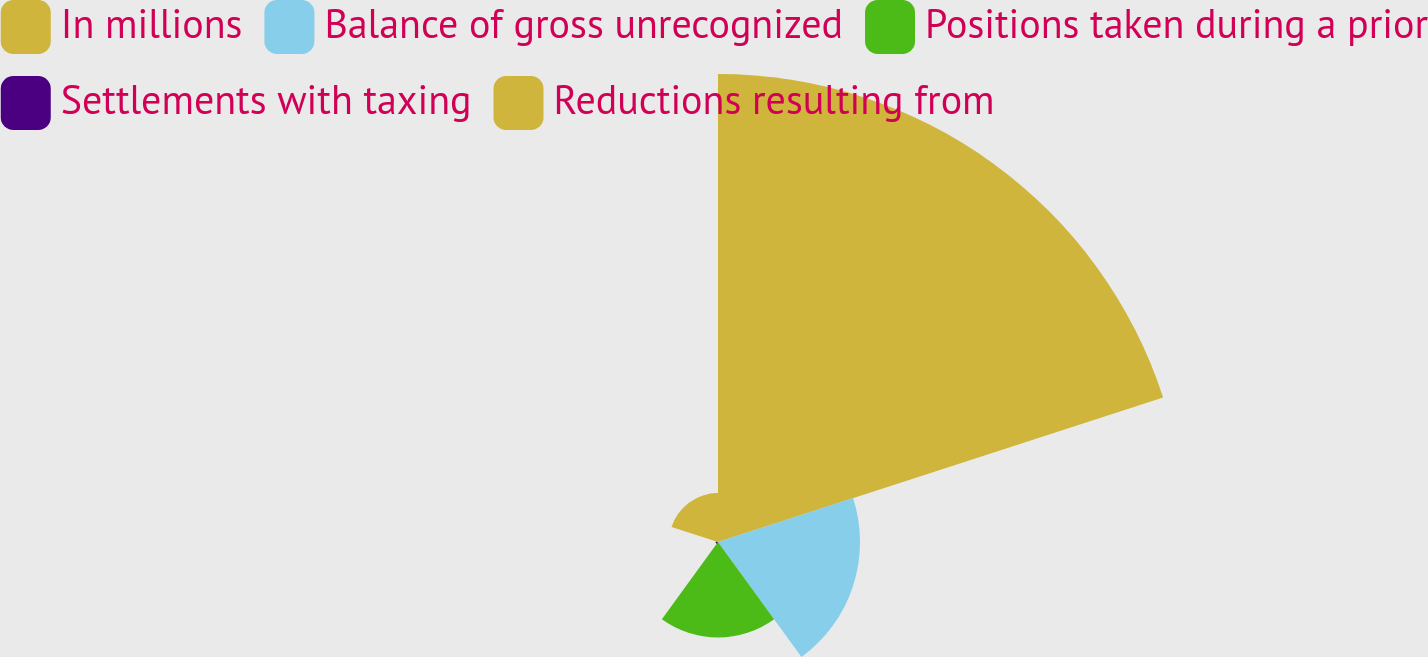Convert chart. <chart><loc_0><loc_0><loc_500><loc_500><pie_chart><fcel>In millions<fcel>Balance of gross unrecognized<fcel>Positions taken during a prior<fcel>Settlements with taxing<fcel>Reductions resulting from<nl><fcel>61.85%<fcel>18.77%<fcel>12.62%<fcel>0.31%<fcel>6.46%<nl></chart> 